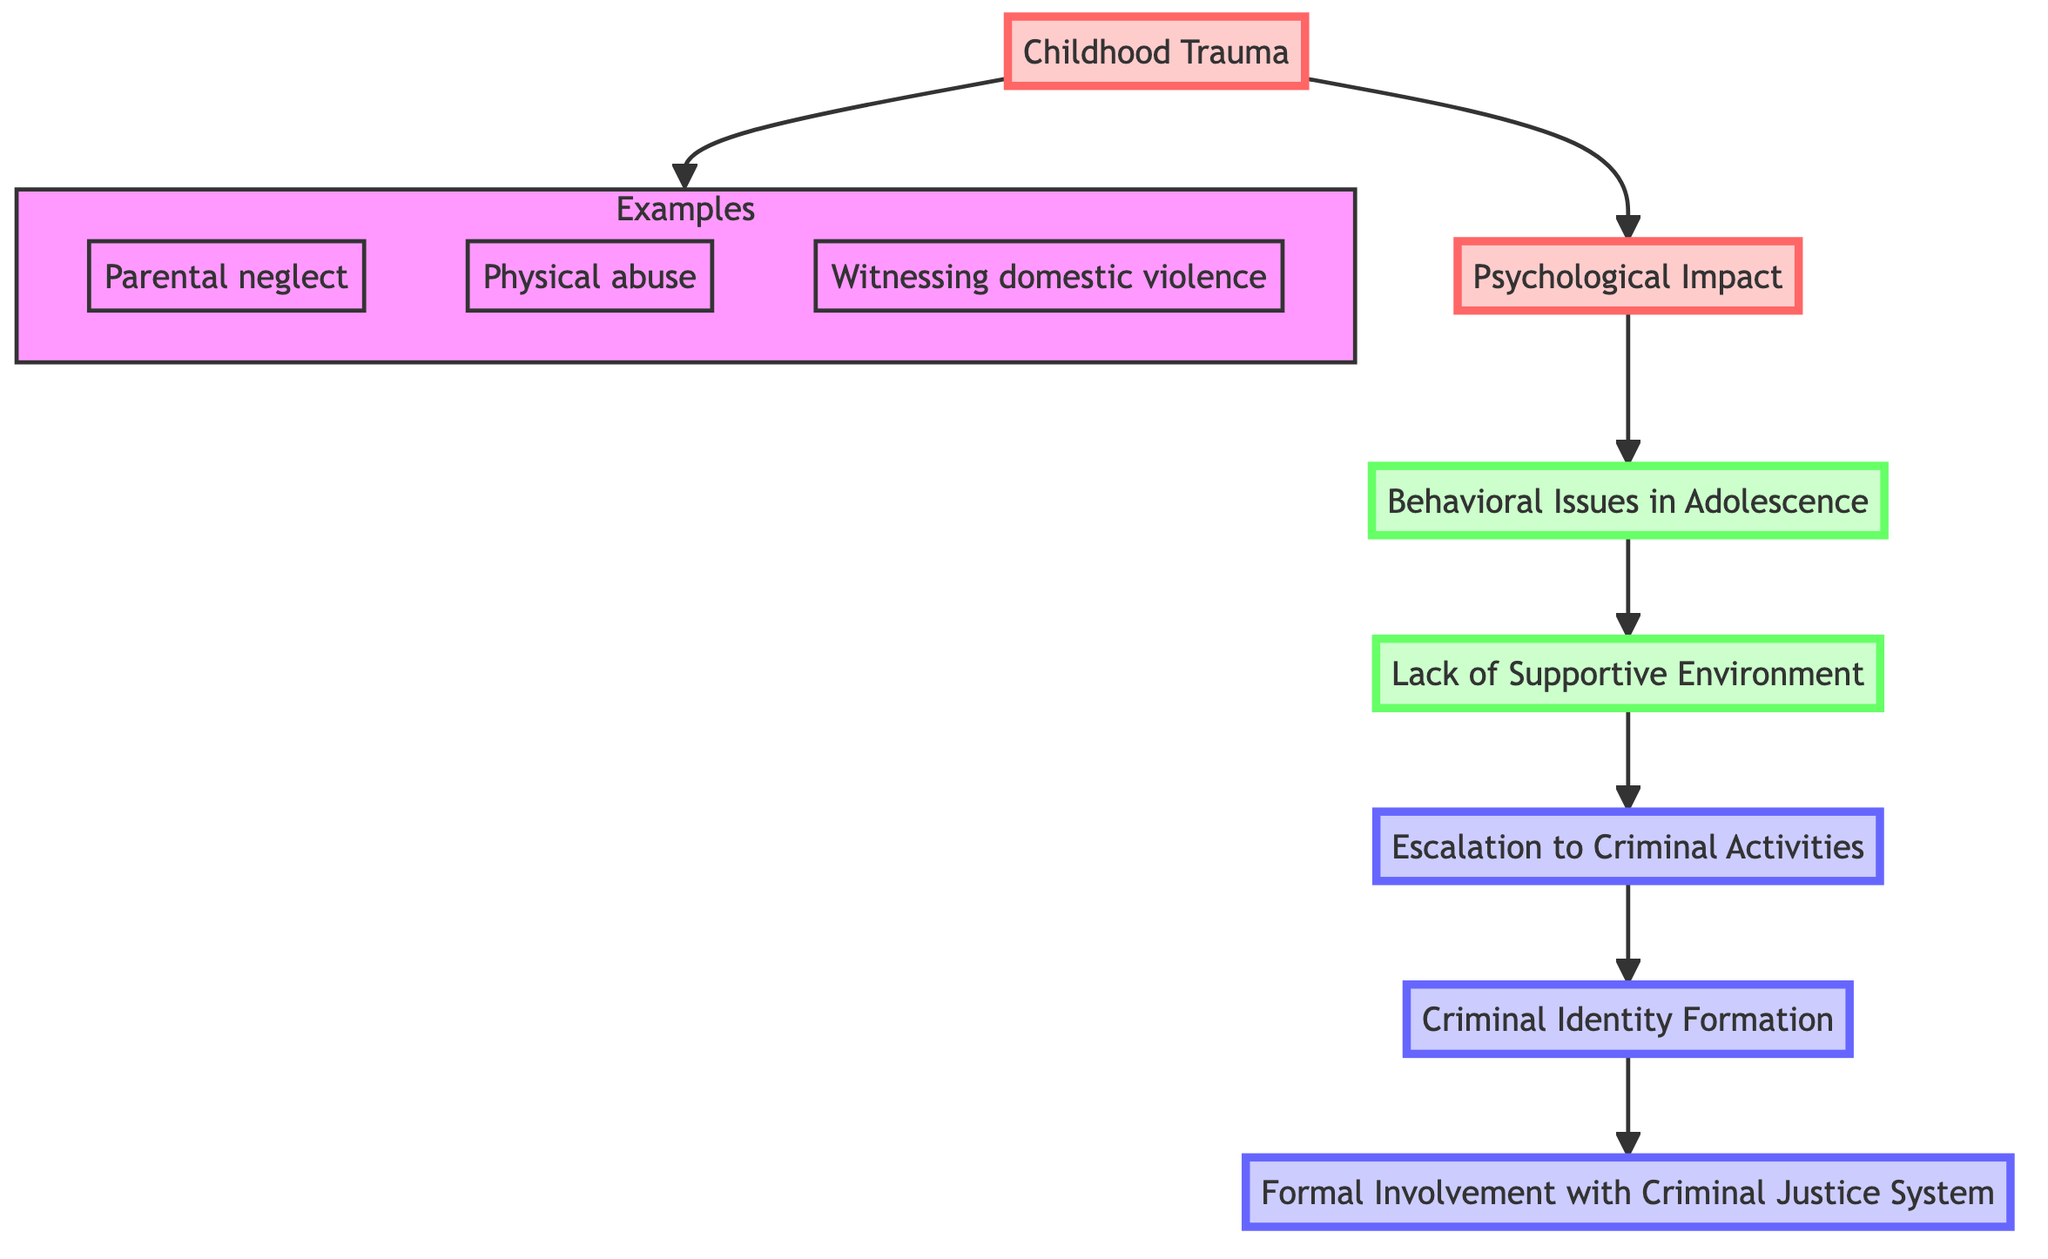What is the first node in the diagram? The first node is identified at the base of the flow chart. It is "Childhood Trauma," which serves as the starting point.
Answer: Childhood Trauma What is the final node in the diagram? The final node is found at the top of the flow chart. It is "Formal Involvement with Criminal Justice System," which represents the end stage of the criminal’s path.
Answer: Formal Involvement with Criminal Justice System How many total nodes are in the diagram? By counting each distinct node involved in the flow, we find there are 7 nodes in total: Childhood Trauma, Psychological Impact, Behavioral Issues in Adolescence, Lack of Supportive Environment, Escalation to Criminal Activities, Criminal Identity Formation, and Formal Involvement with Criminal Justice System.
Answer: 7 What is the relationship between "Escalation to Criminal Activities" and "Criminal Identity Formation"? The relationship is directional, indicating a progression where "Escalation to Criminal Activities" leads to "Criminal Identity Formation," representing a deeper involvement in crime identifying with criminality.
Answer: Leads to Which node directly follows "Psychological Impact"? The flowchart shows that "Behavioral Issues in Adolescence" directly follows "Psychological Impact," signifying a connection between psychological effects and subsequent behavior patterns.
Answer: Behavioral Issues in Adolescence What is indicated by the "Lack of Supportive Environment"? The "Lack of Supportive Environment" is indicated as a contributing factor that exacerbates the issues stemming from earlier nodes, particularly leading to more severe behavioral manifestations and criminal activity.
Answer: Contributing factor What are the examples listed under "Childhood Trauma"? The examples listed under "Childhood Trauma" are "Parental neglect," "Physical abuse," and "Witnessing domestic violence," reflecting the various forms of trauma that can impact individuals in their formative years.
Answer: Parental neglect, Physical abuse, Witnessing domestic violence How do "Behavioral Issues in Adolescence" relate to "Psychological Impact"? "Behavioral Issues in Adolescence" are the manifestations of the "Psychological Impact" stemming from childhood trauma, indicating how emotional and psychological struggles can lead to observable behaviors.
Answer: Manifestation of effects What is the significance of the arrows pointing up in the diagram? The upward arrows signify a progression or flow from one stage to the next, illustrating a causal relationship whereby each preceding node influences the development of subsequent nodes in the path toward crime.
Answer: Progression of stages 